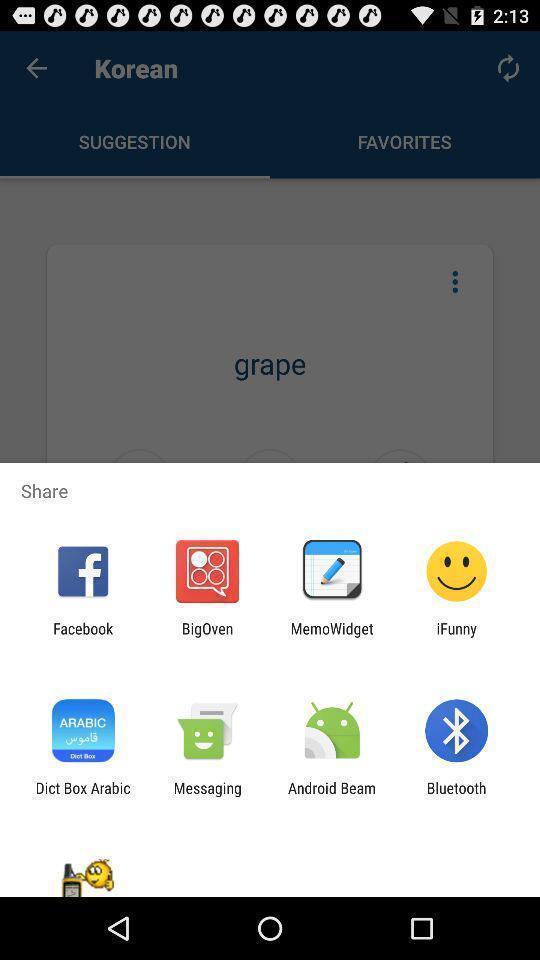Describe this image in words. Share information with different apps. 